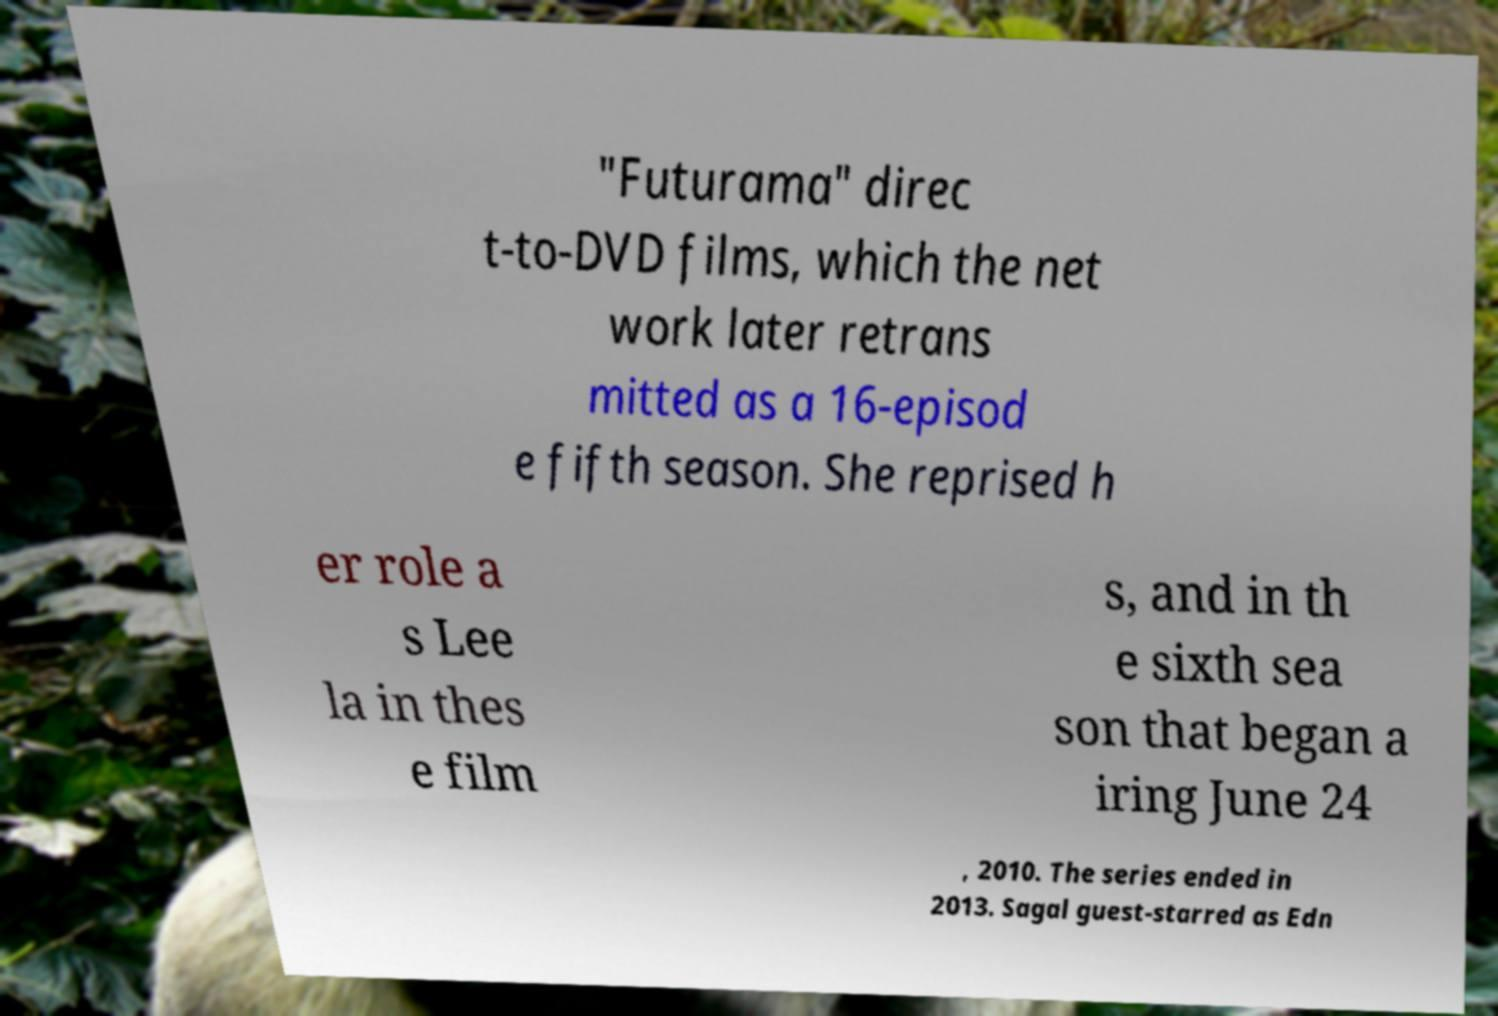There's text embedded in this image that I need extracted. Can you transcribe it verbatim? "Futurama" direc t-to-DVD films, which the net work later retrans mitted as a 16-episod e fifth season. She reprised h er role a s Lee la in thes e film s, and in th e sixth sea son that began a iring June 24 , 2010. The series ended in 2013. Sagal guest-starred as Edn 